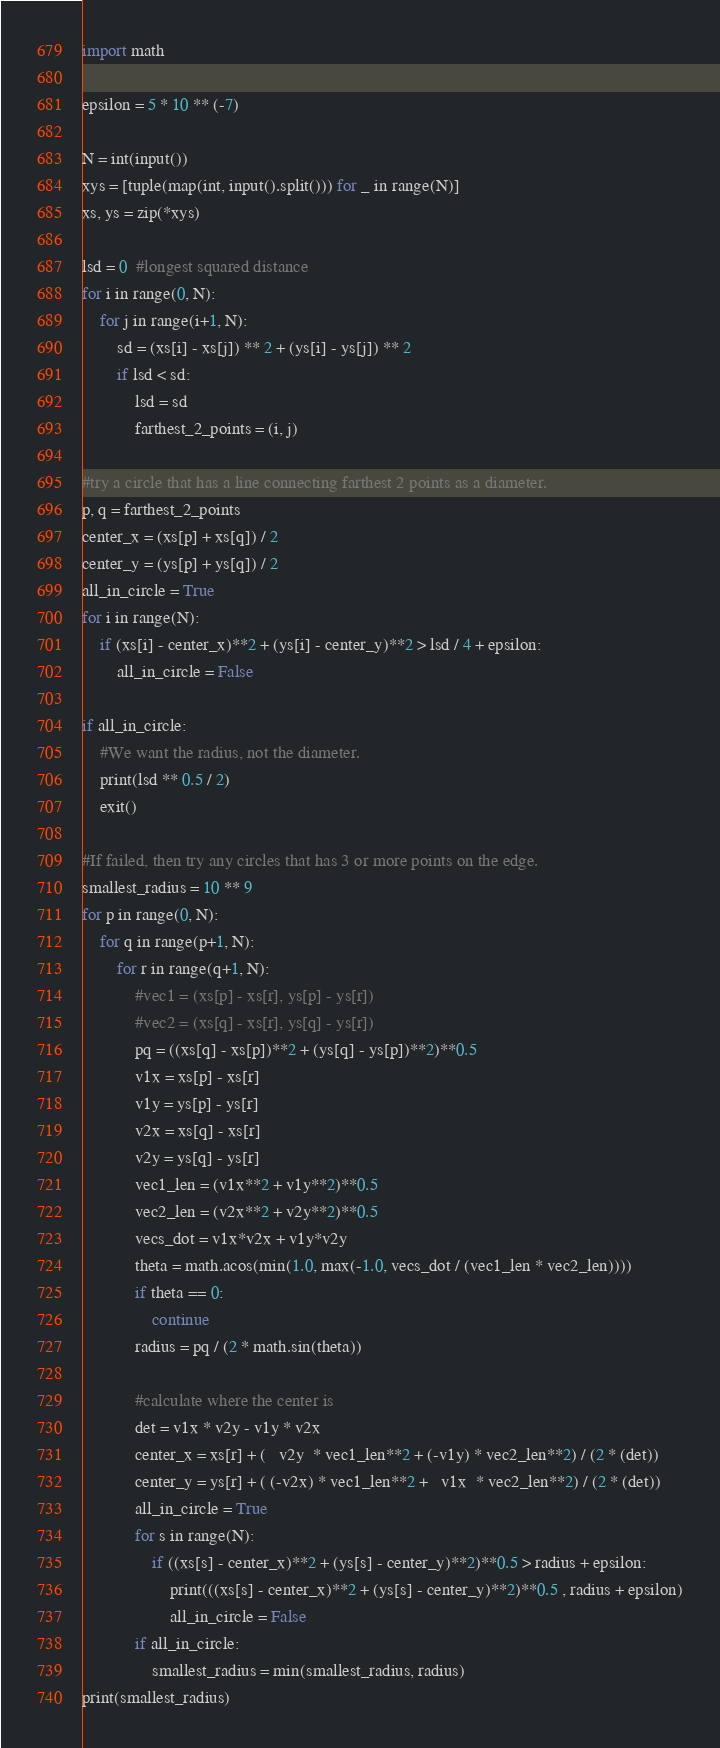Convert code to text. <code><loc_0><loc_0><loc_500><loc_500><_Python_>import math

epsilon = 5 * 10 ** (-7)

N = int(input())
xys = [tuple(map(int, input().split())) for _ in range(N)]
xs, ys = zip(*xys)

lsd = 0  #longest squared distance
for i in range(0, N):
    for j in range(i+1, N):
        sd = (xs[i] - xs[j]) ** 2 + (ys[i] - ys[j]) ** 2 
        if lsd < sd:
            lsd = sd
            farthest_2_points = (i, j)

#try a circle that has a line connecting farthest 2 points as a diameter.
p, q = farthest_2_points
center_x = (xs[p] + xs[q]) / 2
center_y = (ys[p] + ys[q]) / 2
all_in_circle = True
for i in range(N):
    if (xs[i] - center_x)**2 + (ys[i] - center_y)**2 > lsd / 4 + epsilon:
        all_in_circle = False

if all_in_circle:
    #We want the radius, not the diameter.
    print(lsd ** 0.5 / 2)
    exit()

#If failed, then try any circles that has 3 or more points on the edge.
smallest_radius = 10 ** 9
for p in range(0, N):
    for q in range(p+1, N):
        for r in range(q+1, N):
            #vec1 = (xs[p] - xs[r], ys[p] - ys[r])
            #vec2 = (xs[q] - xs[r], ys[q] - ys[r])
            pq = ((xs[q] - xs[p])**2 + (ys[q] - ys[p])**2)**0.5
            v1x = xs[p] - xs[r]
            v1y = ys[p] - ys[r]
            v2x = xs[q] - xs[r]
            v2y = ys[q] - ys[r]
            vec1_len = (v1x**2 + v1y**2)**0.5
            vec2_len = (v2x**2 + v2y**2)**0.5
            vecs_dot = v1x*v2x + v1y*v2y
            theta = math.acos(min(1.0, max(-1.0, vecs_dot / (vec1_len * vec2_len))))
            if theta == 0:
                continue
            radius = pq / (2 * math.sin(theta))

            #calculate where the center is
            det = v1x * v2y - v1y * v2x 
            center_x = xs[r] + (   v2y  * vec1_len**2 + (-v1y) * vec2_len**2) / (2 * (det))
            center_y = ys[r] + ( (-v2x) * vec1_len**2 +   v1x  * vec2_len**2) / (2 * (det))
            all_in_circle = True
            for s in range(N):
                if ((xs[s] - center_x)**2 + (ys[s] - center_y)**2)**0.5 > radius + epsilon:
                    print(((xs[s] - center_x)**2 + (ys[s] - center_y)**2)**0.5 , radius + epsilon)
                    all_in_circle = False
            if all_in_circle:
                smallest_radius = min(smallest_radius, radius)
print(smallest_radius)</code> 